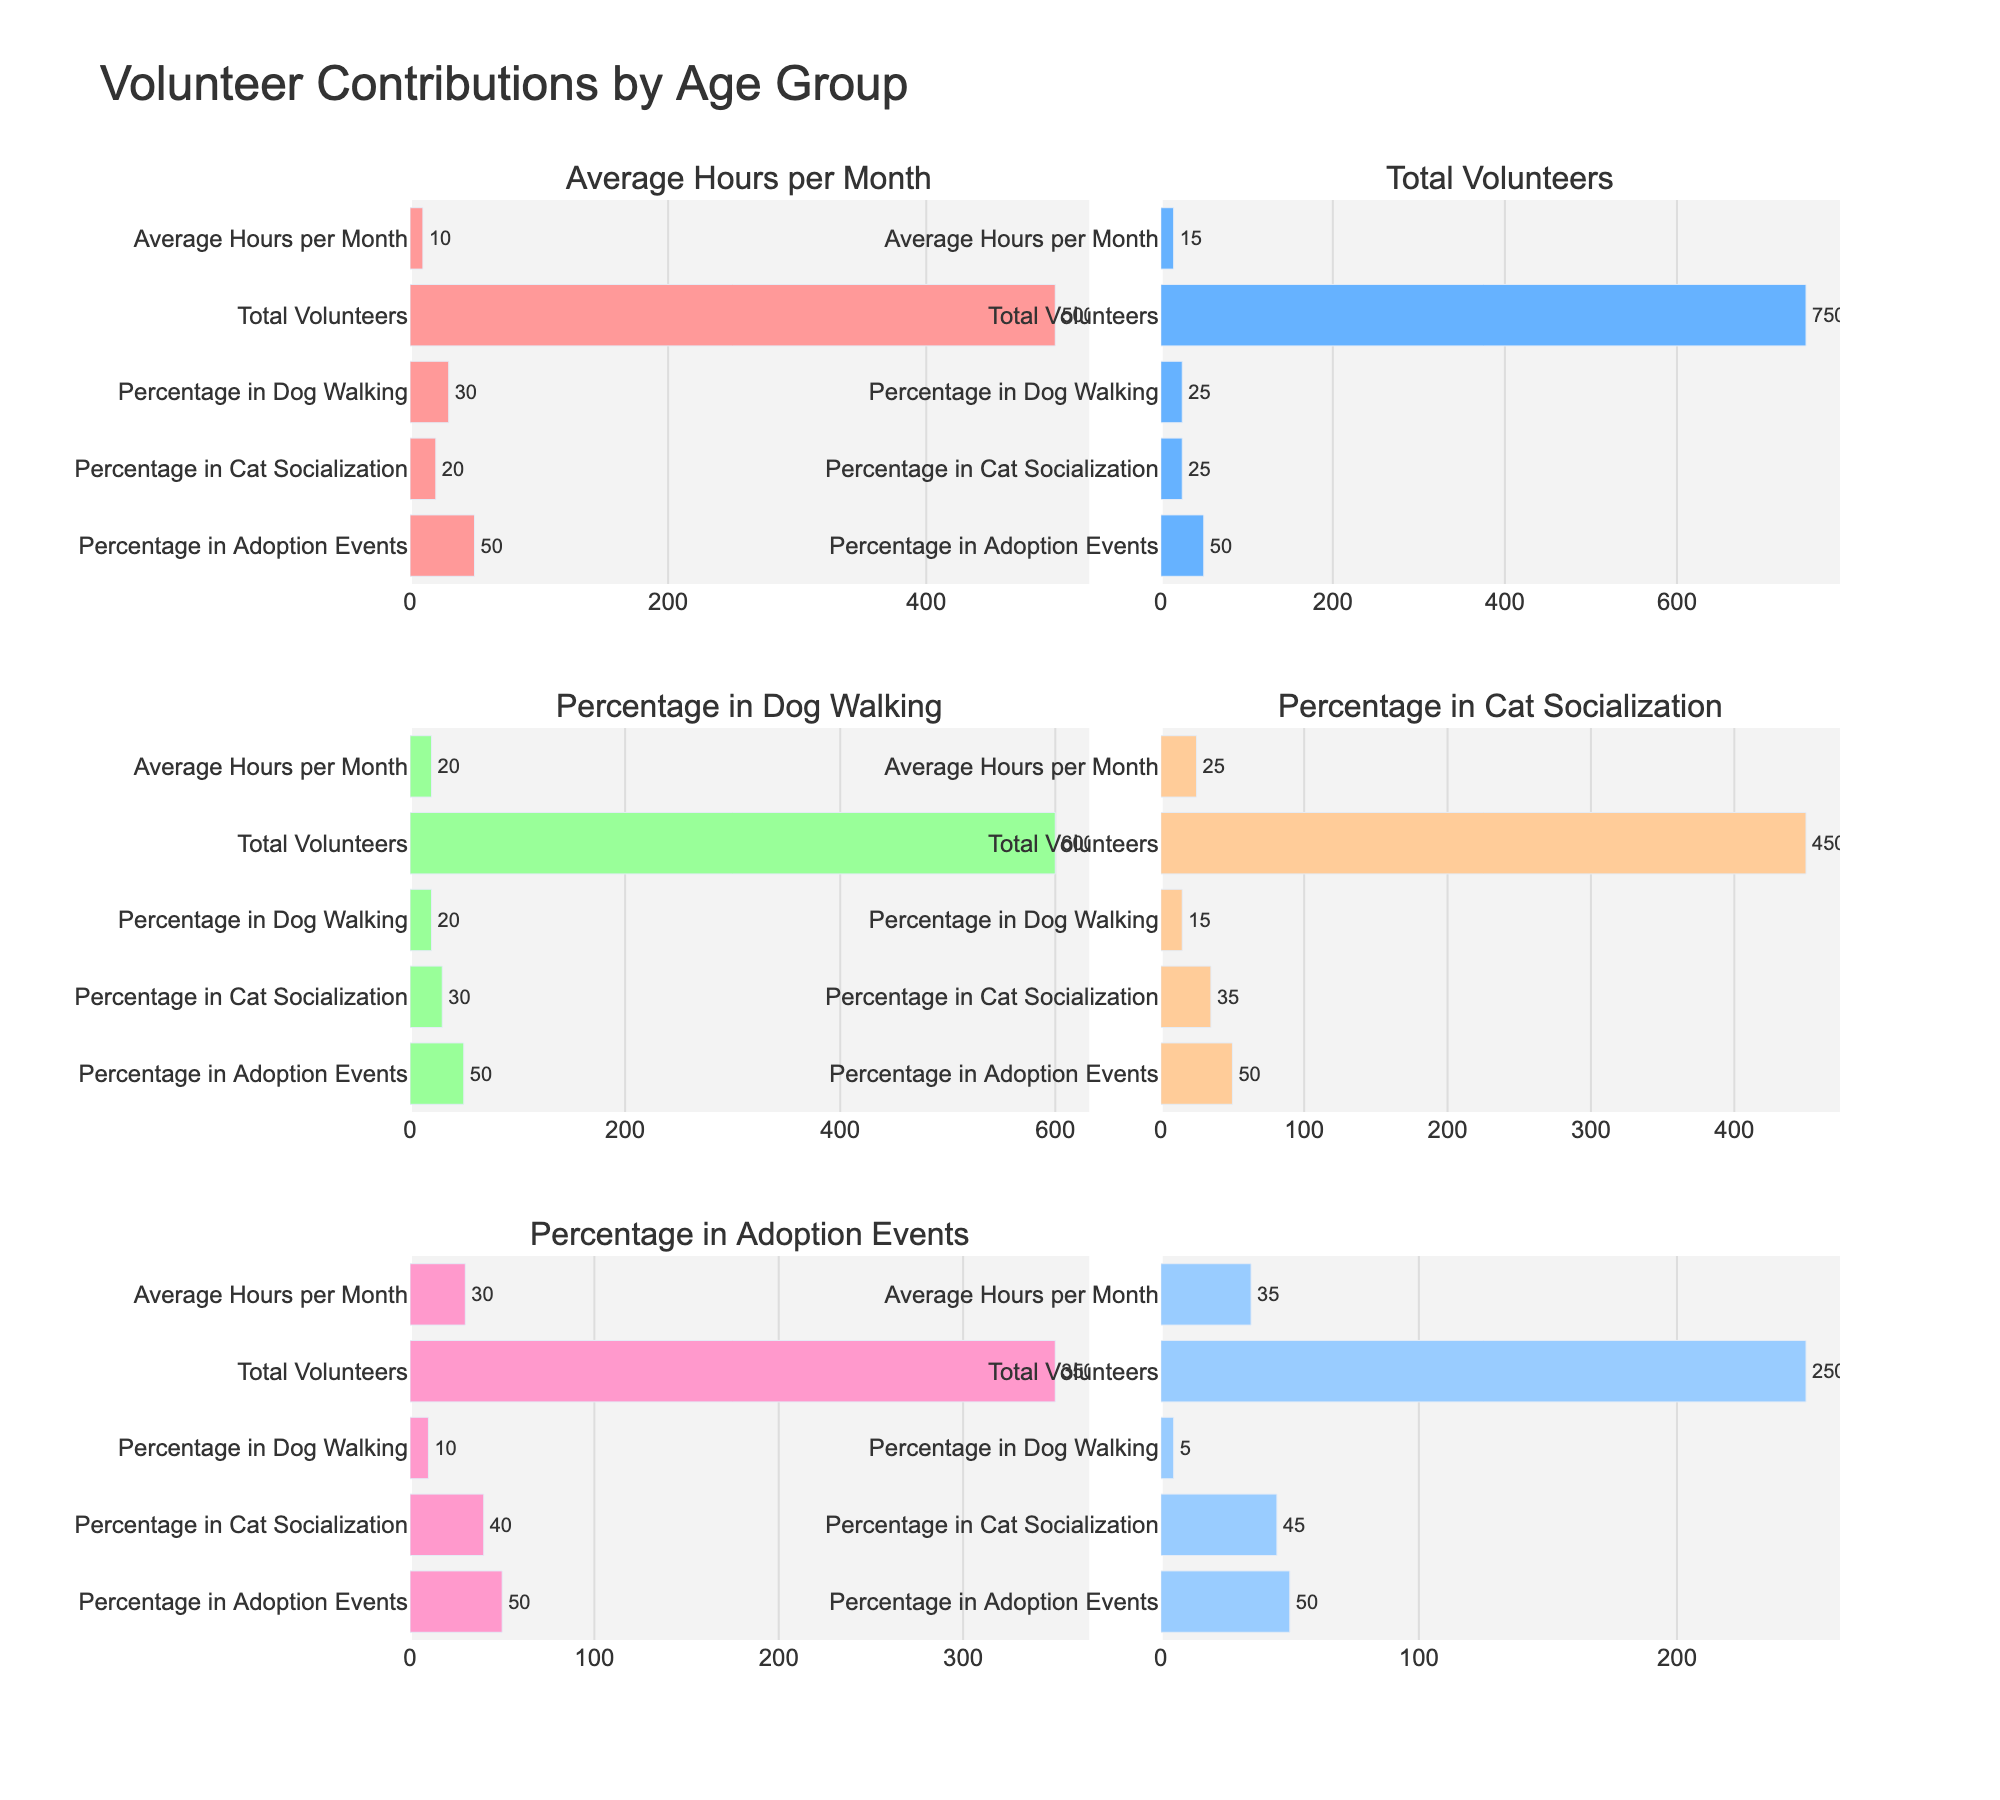What is the average number of volunteer hours per month for the 45-54 age group? According to the subplot titled "Average Hours per Month," the bar for the 45-54 age group indicates 25 hours.
Answer: 25 How many total volunteers are in the 25-34 age group? The subplot titled "Total Volunteers" shows that the bar for the 25-34 age group indicates 750 volunteers.
Answer: 750 Which age group has the highest percentage of volunteers in cat socialization? The subplot titled "Percentage in Cat Socialization" shows that the bar for the 65+ age group is the highest.
Answer: 65+ What is the sum of total volunteers in the 18-24 and 65+ age groups? The subplot titled "Total Volunteers" shows 500 volunteers for the 18-24 age group and 250 for the 65+ age group. Summing these gives 500 + 250 = 750.
Answer: 750 Which age group contributes the most average hours per month? The subplot titled "Average Hours per Month" shows that the 65+ age group has the highest bar, indicating they contribute the most average hours per month.
Answer: 65+ Between the 35-44 and 45-54 age groups, which one has a higher percentage of volunteers in dog walking? The subplot titled "Percentage in Dog Walking" shows 20% for the 35-44 age group and 15% for the 45-54 age group. The 35-44 age group has a higher percentage.
Answer: 35-44 What is the median number of total volunteers across all age groups? The total volunteers per age group are 500, 750, 600, 450, 350, and 250. Arranging these in order: 250, 350, 450, 500, 600, 750. The median is the average of 450 and 500, i.e., (450 + 500) / 2 = 475.
Answer: 475 What percentage of volunteers in the 55-64 age group participate in adoption events? The subplot titled "Percentage in Adoption Events" shows that the percentage for all age groups is flat at 50%.
Answer: 50 Which two age groups have the equal percentage of volunteers in adoption events? The subplot titled "Percentage in Adoption Events" shows all age groups have the same percentage, which is 50%.
Answer: All groups If a person wanted to join an age group with a high focus on adoption events, which group should they consider? Since the "Percentage in Adoption Events" subplot shows all age groups having 50%, any age group is suitable.
Answer: Any 